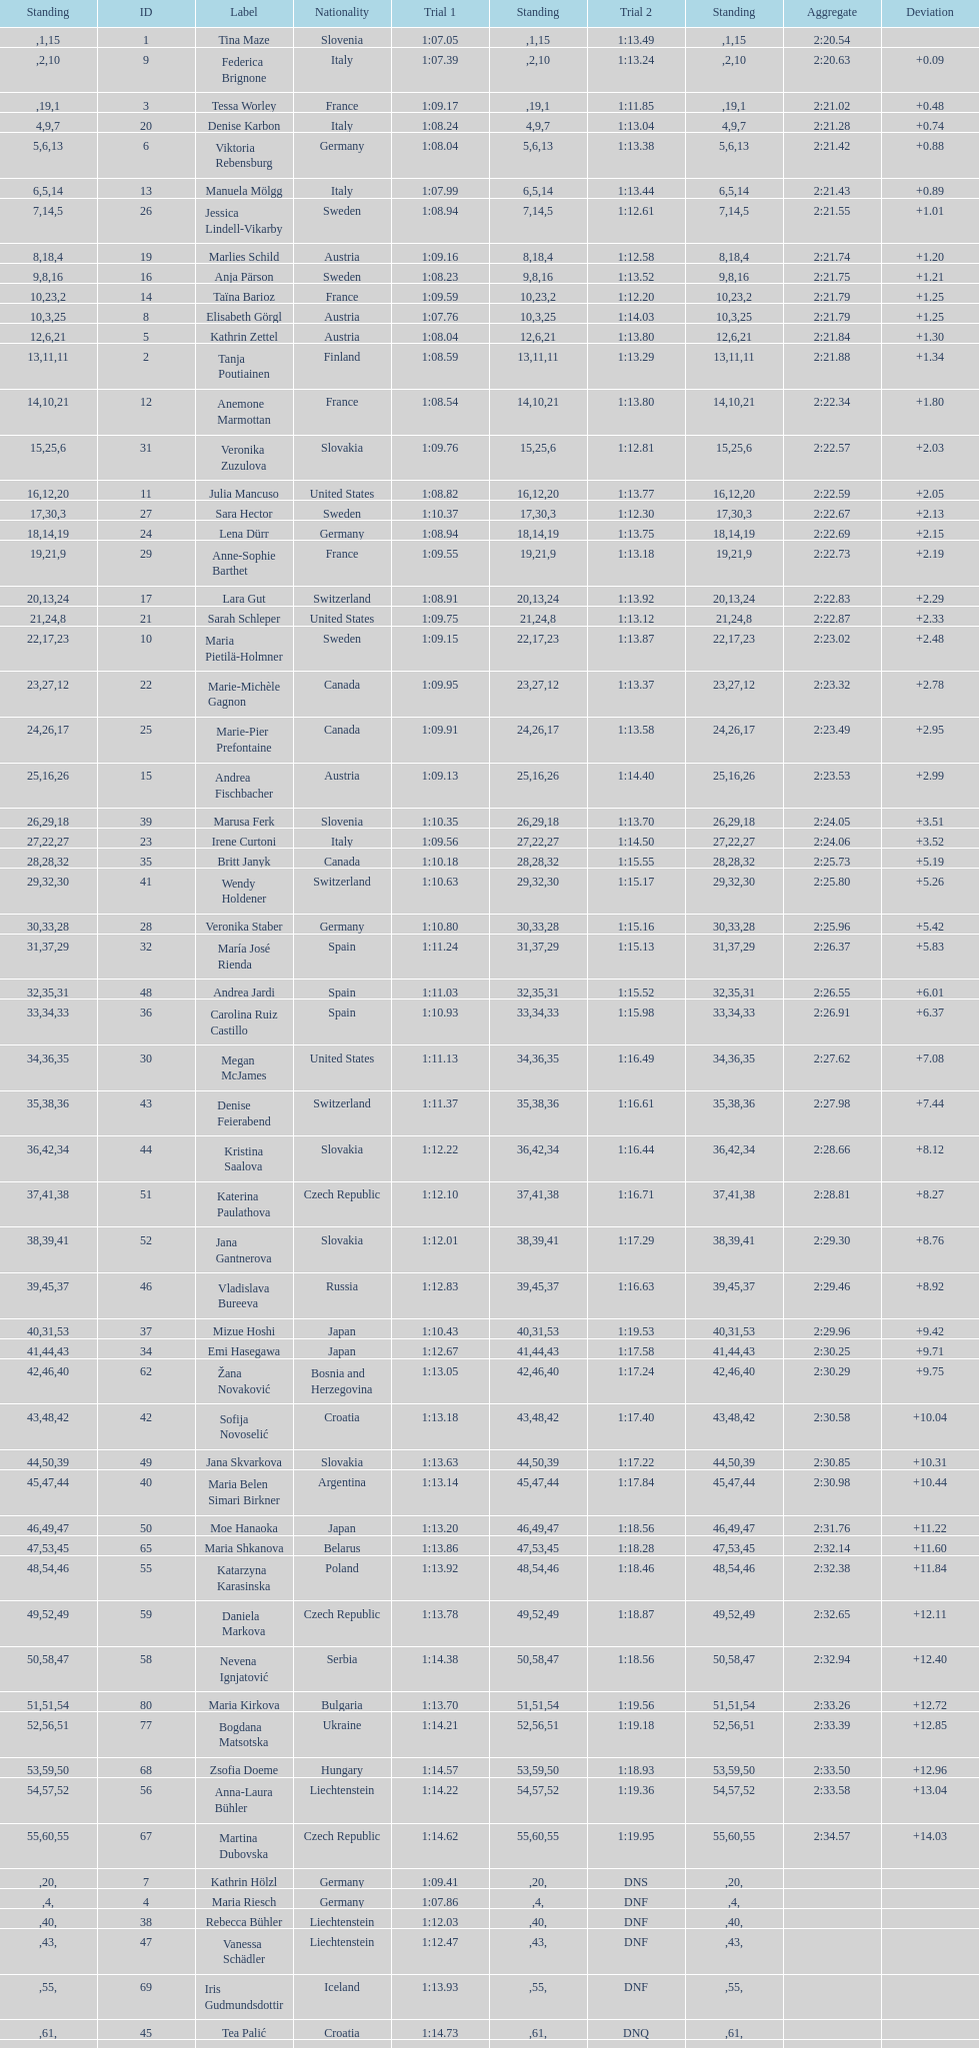Who ranked next after federica brignone? Tessa Worley. 